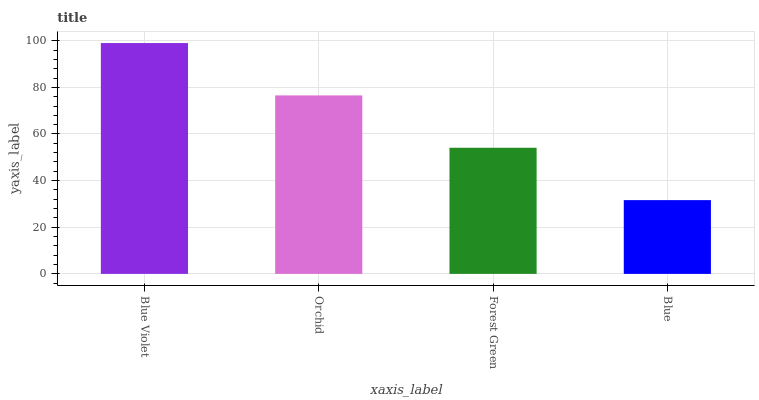Is Blue the minimum?
Answer yes or no. Yes. Is Blue Violet the maximum?
Answer yes or no. Yes. Is Orchid the minimum?
Answer yes or no. No. Is Orchid the maximum?
Answer yes or no. No. Is Blue Violet greater than Orchid?
Answer yes or no. Yes. Is Orchid less than Blue Violet?
Answer yes or no. Yes. Is Orchid greater than Blue Violet?
Answer yes or no. No. Is Blue Violet less than Orchid?
Answer yes or no. No. Is Orchid the high median?
Answer yes or no. Yes. Is Forest Green the low median?
Answer yes or no. Yes. Is Blue the high median?
Answer yes or no. No. Is Blue the low median?
Answer yes or no. No. 